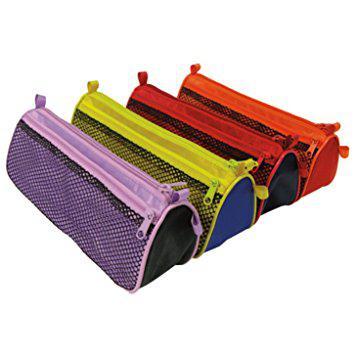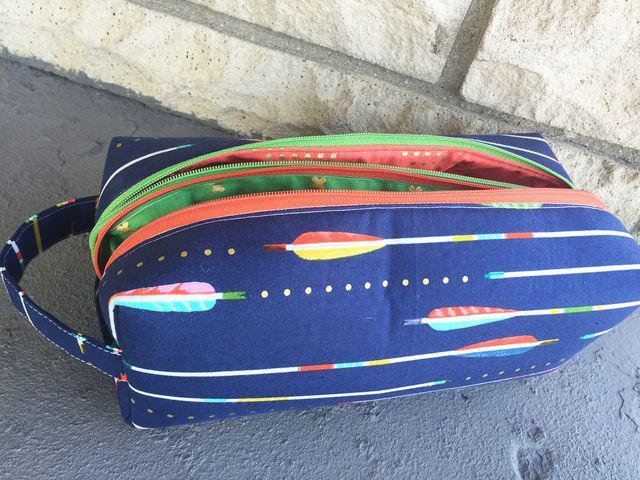The first image is the image on the left, the second image is the image on the right. For the images shown, is this caption "A pencil case in one image is multicolored with a top zipper, while four zippered cases in the second image are a different style." true? Answer yes or no. Yes. The first image is the image on the left, the second image is the image on the right. Evaluate the accuracy of this statement regarding the images: "there is a pencil pouch with flamingos and flowers on it". Is it true? Answer yes or no. No. 